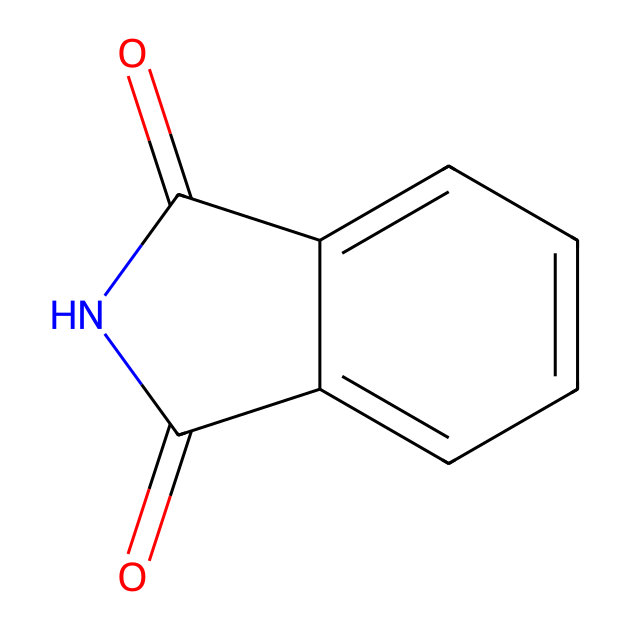What is the name of this chemical? The chemical structure corresponds to phthalimide, which is an imide based on phthalic anhydride. This can be identified by the carbonyl (C=O) groups adjacent to the nitrogen atom.
Answer: phthalimide How many carbon atoms are present in phthalimide? By analyzing the SMILES representation, there are 8 carbon atoms within the structure, as indicated by the letter 'c' in the structure and the two 'C' accounting for the carbonyl carbons.
Answer: 8 What type of functional groups are present in phthalimide? The structure features imide functional groups, characterized by the presence of the nitrogen (N) between two carbonyl (C=O) groups. This imide is derived from the reaction of a carboxylic acid with an amine.
Answer: imide What is the degree of unsaturation in phthalimide? To calculate the degree of unsaturation, we consider the number of rings and/or multiple bonds; in this case, there are 2 rings and 2 carbonyl groups contributing to the unsaturation. Thus, the degree of unsaturation is 4.
Answer: 4 How many nitrogen atoms are present in the chemical? The SMILES structure indicates one nitrogen atom is present, as denoted by the 'N' in the representation. There are no multiple nitrogen atoms in this imide structure.
Answer: 1 Is phthalimide a primary, secondary, or tertiary amide? Phthalimide can be identified as a secondary amide, where the nitrogen is bonded to two carbon groups (the carbonyls), and is typically featured in reactions to yield primary amines through Gabriel synthesis.
Answer: secondary 